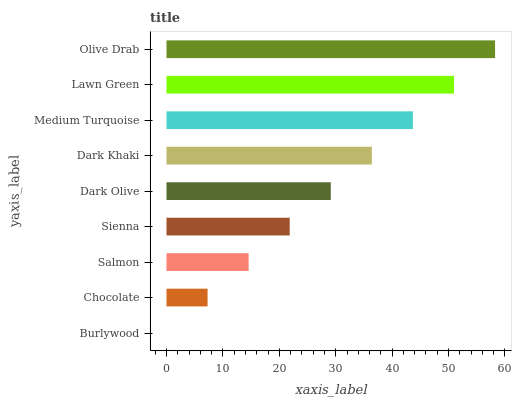Is Burlywood the minimum?
Answer yes or no. Yes. Is Olive Drab the maximum?
Answer yes or no. Yes. Is Chocolate the minimum?
Answer yes or no. No. Is Chocolate the maximum?
Answer yes or no. No. Is Chocolate greater than Burlywood?
Answer yes or no. Yes. Is Burlywood less than Chocolate?
Answer yes or no. Yes. Is Burlywood greater than Chocolate?
Answer yes or no. No. Is Chocolate less than Burlywood?
Answer yes or no. No. Is Dark Olive the high median?
Answer yes or no. Yes. Is Dark Olive the low median?
Answer yes or no. Yes. Is Dark Khaki the high median?
Answer yes or no. No. Is Olive Drab the low median?
Answer yes or no. No. 